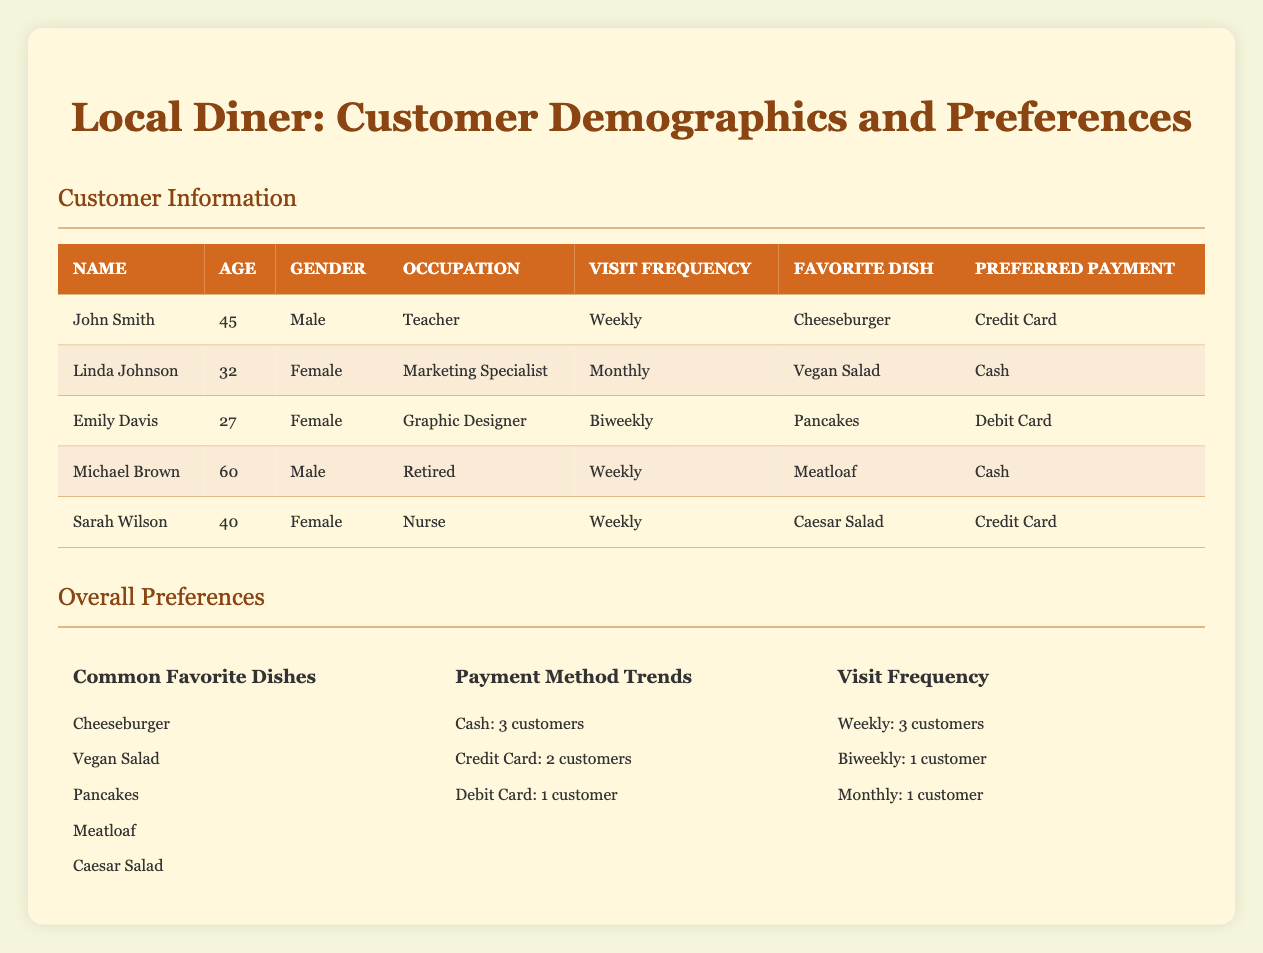What is the favorite dish of Linda Johnson? Linda Johnson's favorite dish is listed in the table under the 'Favorite Dish' column. It indicates that her favorite dish is "Vegan Salad."
Answer: Vegan Salad How many customers prefer to pay with cash? The table provides a summary of payment methods used by customers. According to the 'Payment Method Trends' section, 3 customers prefer to pay with cash.
Answer: 3 customers What is the average age of the customers who visit the diner weekly? We look at the customers with a 'Visit Frequency' of "Weekly." John Smith (45), Michael Brown (60), and Sarah Wilson (40) are the customers in this category. The average age is calculated as (45 + 60 + 40) / 3 = 145 / 3 = 48.33, which can be approximated to 48.
Answer: 48 Which gender has more customers visiting the diner? The table shows customer gender: John Smith (Male), Linda Johnson (Female), Emily Davis (Female), Michael Brown (Male), and Sarah Wilson (Female). Counting the customers by gender, there are 2 males and 3 females. Therefore, females have more customers visiting the diner.
Answer: Females How many customers visited the diner on a biweekly basis? The customer's visit frequency shows that there is one customer listed as visiting biweekly. This is noted in Emily Davis's entry.
Answer: 1 customer Is there any customer who prefers a debit card as their payment method? According to the 'Payment Method Trends', it lists that 1 customer prefers using a debit card, which corresponds to Emily Davis's payment preference, thus confirming the statement as true.
Answer: Yes What is the most common favorite dish among the customers? The most common favorite dish can be found in the 'Common Favorite Dishes' list, which contains five dishes. There is no indication of any dish being repeated, so they all seem equally common, placing "Cheeseburger" as the first one listed.
Answer: Cheeseburger How many customers are there in total who visit biweekly or monthly? The analysis requires adding the customers from the 'Visit Frequency' section who are biweekly (1) and monthly (1), resulting in a total of 1 + 1 = 2 customers who visit biweekly or monthly.
Answer: 2 customers What percentage of customers visit the diner weekly? From the total of 5 customers, 3 visit weekly. The percentage is calculated as (3 / 5) * 100 = 60%. Thus, 60% of the customers are weekly visitors.
Answer: 60% 